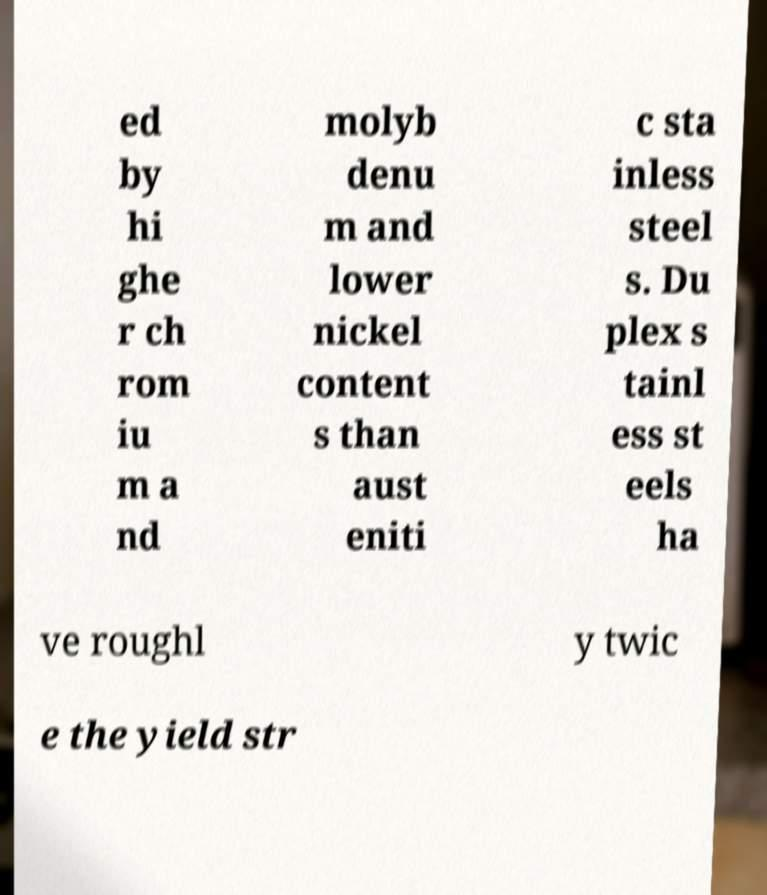I need the written content from this picture converted into text. Can you do that? ed by hi ghe r ch rom iu m a nd molyb denu m and lower nickel content s than aust eniti c sta inless steel s. Du plex s tainl ess st eels ha ve roughl y twic e the yield str 